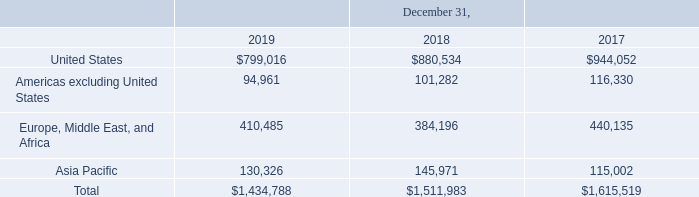Geographic and Other Information
Revenue by geographic region, based on ship-to destinations, was as follows (in thousands):
The United States represented 56%, 58% and 58% of revenue for 2019, 2018 and 2017, respectively. Revenue in the United Kingdom was $159.9 million in 2019 and $196.0 million in 2017, representing 11% of revenue in 2019 and 12% of revenue for 2017. Revenue in the United Kingdom was less than 10% of revenue in 2018. No other single country represented more than 10% of revenue during these periods. As of December 31, 2019 and 2018, long-lived assets, which represent property and equipment, located outside the United States were $27.9 million and $36.9 million, respectively.
What is the amount of revenue in the United Kingdom in 2019? $159.9 million. What is the value of long-lived assets located outside the United States as of December 31, 2018? $36.9 million. What is the percentage constitution of revenue from the United States for 2019? 56%. What is the average revenue from the United States from 2017 to 2019?
Answer scale should be: thousand. (799,016+880,534+944,052)/3
Answer: 874534. What is the percentage constitution of revenue from Asia Pacific among the total revenue in 2019?
Answer scale should be: percent. 130,326/1,434,788
Answer: 9.08. What is the difference in total revenue between 2017 and 2018?
Answer scale should be: thousand. 1,615,519-1,511,983
Answer: 103536. 